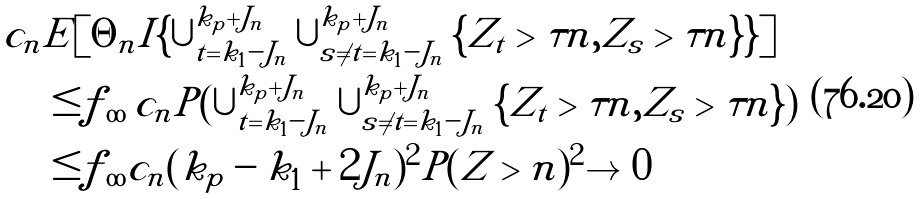<formula> <loc_0><loc_0><loc_500><loc_500>c _ { n } & E [ \Theta _ { n } I \{ \cup _ { t = k _ { 1 } - J _ { n } } ^ { k _ { p } + J _ { n } } \cup _ { s \neq t = k _ { 1 } - J _ { n } } ^ { k _ { p } + J _ { n } } \{ | Z _ { t } | > \tau n , | Z _ { s } | > \tau n \} \} ] \\ & \leq | f | _ { \infty } \, c _ { n } P ( \cup _ { t = k _ { 1 } - J _ { n } } ^ { k _ { p } + J _ { n } } \cup _ { s \neq t = k _ { 1 } - J _ { n } } ^ { k _ { p } + J _ { n } } \{ | Z _ { t } | > \tau n , | Z _ { s } | > \tau n \} ) \\ & \leq | f | _ { \infty } c _ { n } ( k _ { p } - k _ { 1 } + 2 J _ { n } ) ^ { 2 } P ( | Z | > n ) ^ { 2 } \to 0</formula> 